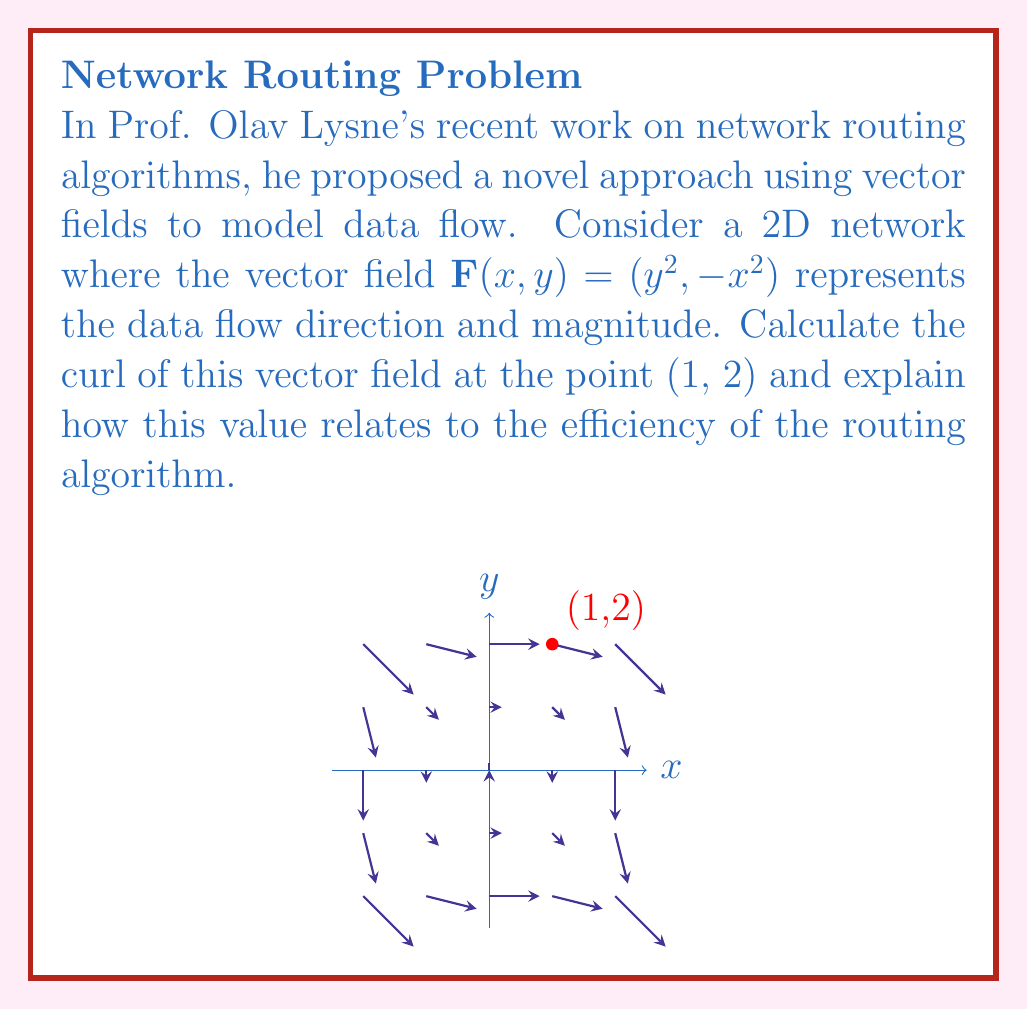Can you answer this question? To analyze the efficiency of the routing algorithm using the curl of the vector field, we'll follow these steps:

1) The curl of a 2D vector field $\mathbf{F}(x,y) = (P(x,y), Q(x,y))$ is given by:

   $$\text{curl } \mathbf{F} = \frac{\partial Q}{\partial x} - \frac{\partial P}{\partial y}$$

2) In our case, $P(x,y) = y^2$ and $Q(x,y) = -x^2$. Let's calculate the partial derivatives:

   $$\frac{\partial Q}{\partial x} = -2x$$
   $$\frac{\partial P}{\partial y} = 2y$$

3) Now, we can calculate the curl:

   $$\text{curl } \mathbf{F} = \frac{\partial Q}{\partial x} - \frac{\partial P}{\partial y} = -2x - 2y$$

4) At the point (1, 2), we have:

   $$\text{curl } \mathbf{F}(1,2) = -2(1) - 2(2) = -6$$

5) Interpretation: The curl measures the rotational tendency of the vector field. In the context of routing algorithms:

   - A non-zero curl indicates the presence of circular flows or eddies in the data movement.
   - A negative curl (as in this case) suggests a clockwise rotation tendency.
   - The magnitude of the curl (6 in this case) indicates the strength of this rotational tendency.

6) Efficiency implications:
   - A high magnitude of curl suggests potential inefficiencies in the routing algorithm, as data might be moving in circles rather than directly to its destination.
   - The negative value indicates a clockwise tendency, which could be used to optimize the algorithm by adjusting routes to counteract this rotation.
   - Prof. Lysne might use this information to refine the routing algorithm, perhaps by introducing compensating factors in the opposite direction of the curl to straighten out data paths and improve efficiency.
Answer: Curl = -6; indicates clockwise rotation tendency and potential routing inefficiency. 